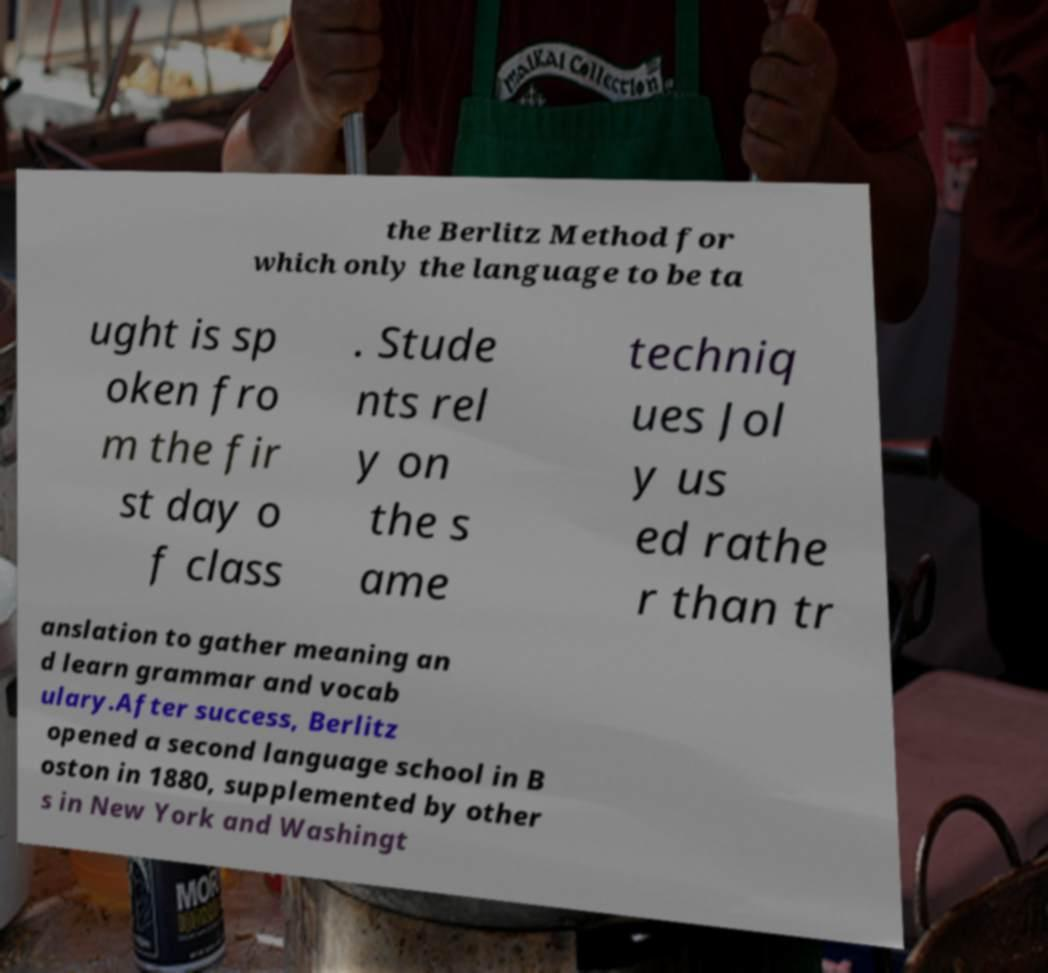There's text embedded in this image that I need extracted. Can you transcribe it verbatim? the Berlitz Method for which only the language to be ta ught is sp oken fro m the fir st day o f class . Stude nts rel y on the s ame techniq ues Jol y us ed rathe r than tr anslation to gather meaning an d learn grammar and vocab ulary.After success, Berlitz opened a second language school in B oston in 1880, supplemented by other s in New York and Washingt 